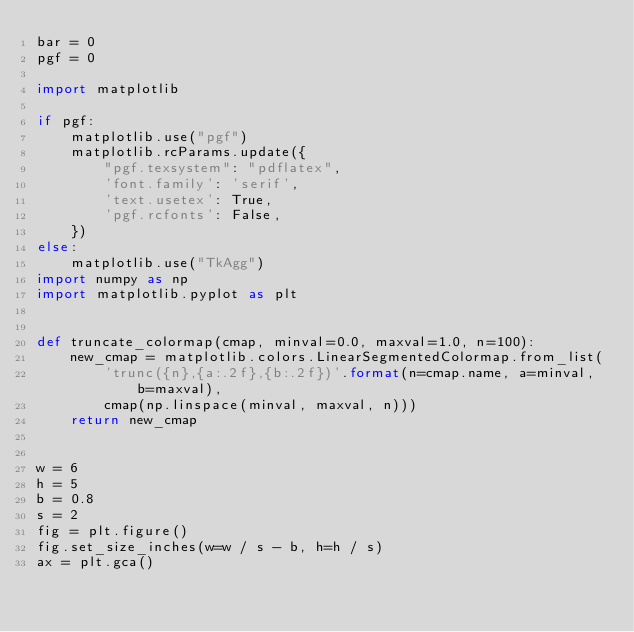Convert code to text. <code><loc_0><loc_0><loc_500><loc_500><_Python_>bar = 0
pgf = 0

import matplotlib

if pgf:
    matplotlib.use("pgf")
    matplotlib.rcParams.update({
        "pgf.texsystem": "pdflatex",
        'font.family': 'serif',
        'text.usetex': True,
        'pgf.rcfonts': False,
    })
else:
    matplotlib.use("TkAgg")
import numpy as np
import matplotlib.pyplot as plt


def truncate_colormap(cmap, minval=0.0, maxval=1.0, n=100):
    new_cmap = matplotlib.colors.LinearSegmentedColormap.from_list(
        'trunc({n},{a:.2f},{b:.2f})'.format(n=cmap.name, a=minval, b=maxval),
        cmap(np.linspace(minval, maxval, n)))
    return new_cmap


w = 6
h = 5
b = 0.8
s = 2
fig = plt.figure()
fig.set_size_inches(w=w / s - b, h=h / s)
ax = plt.gca()</code> 